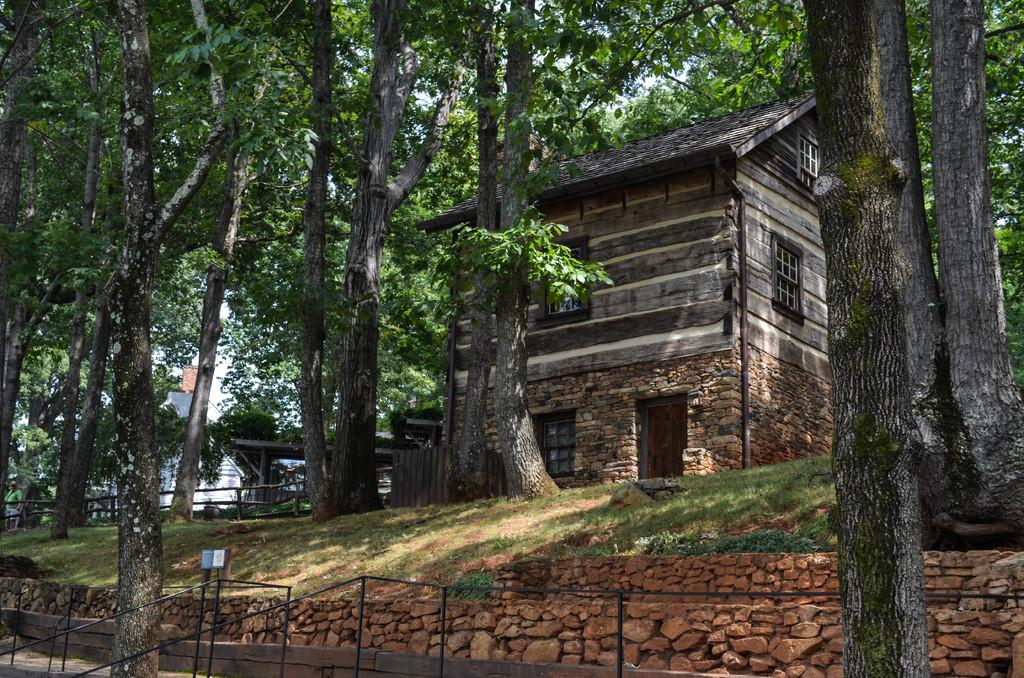What is the main structure in the center of the image? There is a shed in the center of the image. What type of vegetation can be seen in the image? There are trees visible in the image. What might be used for safety or support at the bottom of the image? There are railings at the bottom of the image. What type of ground cover is visible in the image? There is grass visible in the image. What is visible in the background of the image? The sky is visible in the background of the image. Can you see any cats playing near the lake in the image? There is no lake or cat present in the image. 